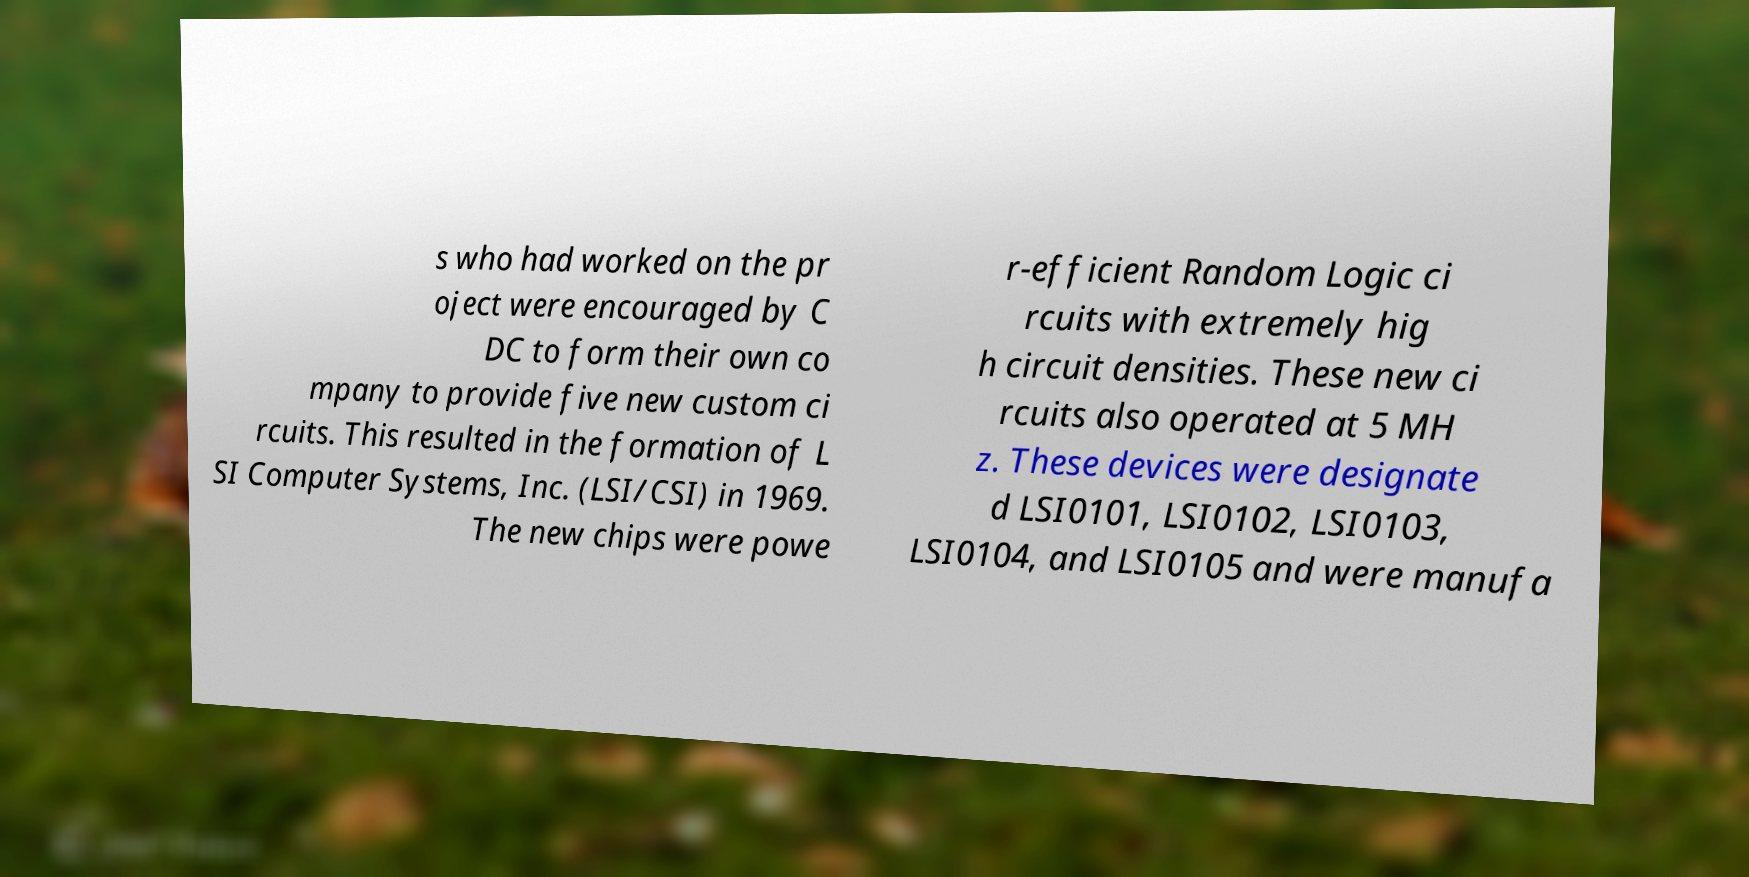For documentation purposes, I need the text within this image transcribed. Could you provide that? s who had worked on the pr oject were encouraged by C DC to form their own co mpany to provide five new custom ci rcuits. This resulted in the formation of L SI Computer Systems, Inc. (LSI/CSI) in 1969. The new chips were powe r-efficient Random Logic ci rcuits with extremely hig h circuit densities. These new ci rcuits also operated at 5 MH z. These devices were designate d LSI0101, LSI0102, LSI0103, LSI0104, and LSI0105 and were manufa 